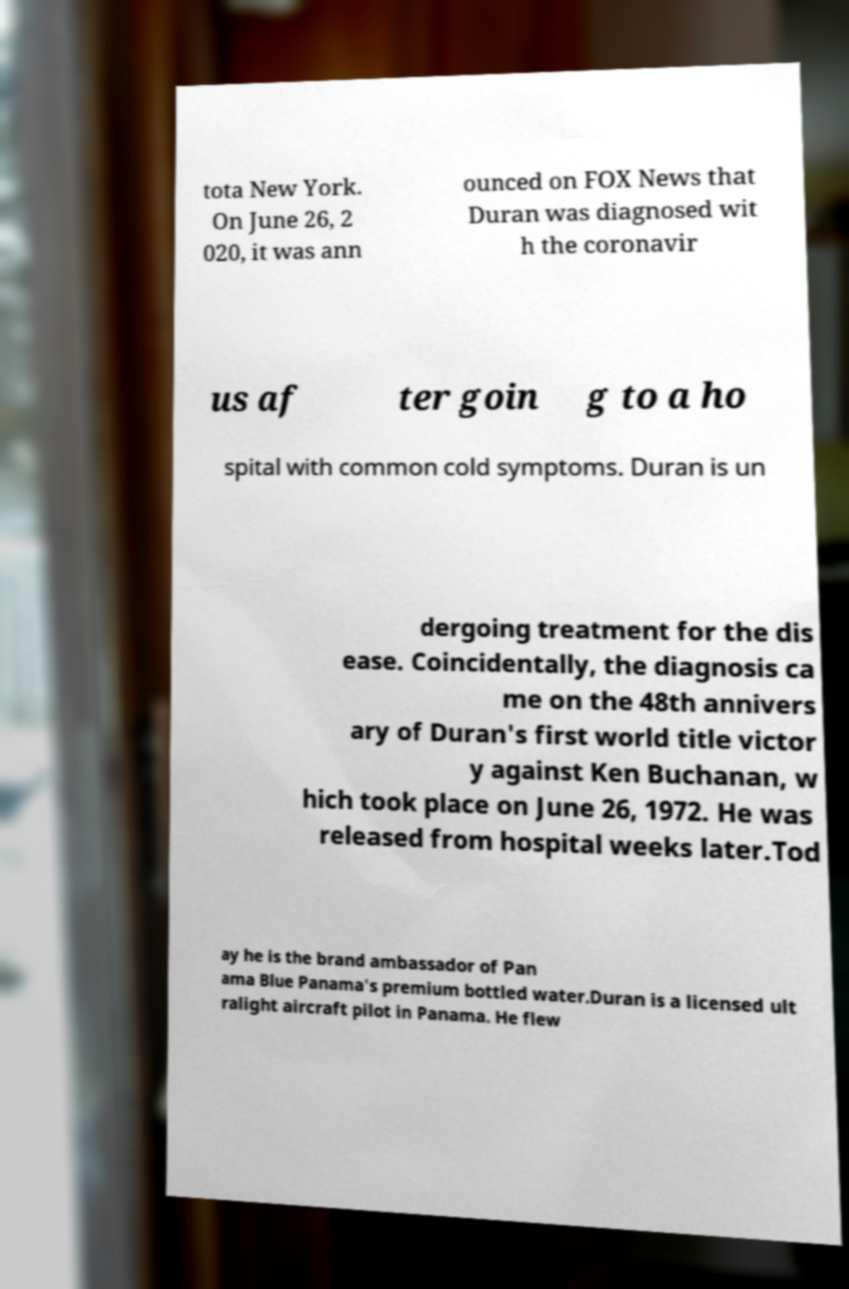Could you extract and type out the text from this image? tota New York. On June 26, 2 020, it was ann ounced on FOX News that Duran was diagnosed wit h the coronavir us af ter goin g to a ho spital with common cold symptoms. Duran is un dergoing treatment for the dis ease. Coincidentally, the diagnosis ca me on the 48th annivers ary of Duran's first world title victor y against Ken Buchanan, w hich took place on June 26, 1972. He was released from hospital weeks later.Tod ay he is the brand ambassador of Pan ama Blue Panama's premium bottled water.Duran is a licensed ult ralight aircraft pilot in Panama. He flew 